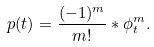Convert formula to latex. <formula><loc_0><loc_0><loc_500><loc_500>p ( t ) = \frac { ( - 1 ) ^ { m } } { m ! } * \phi _ { t } ^ { m } .</formula> 